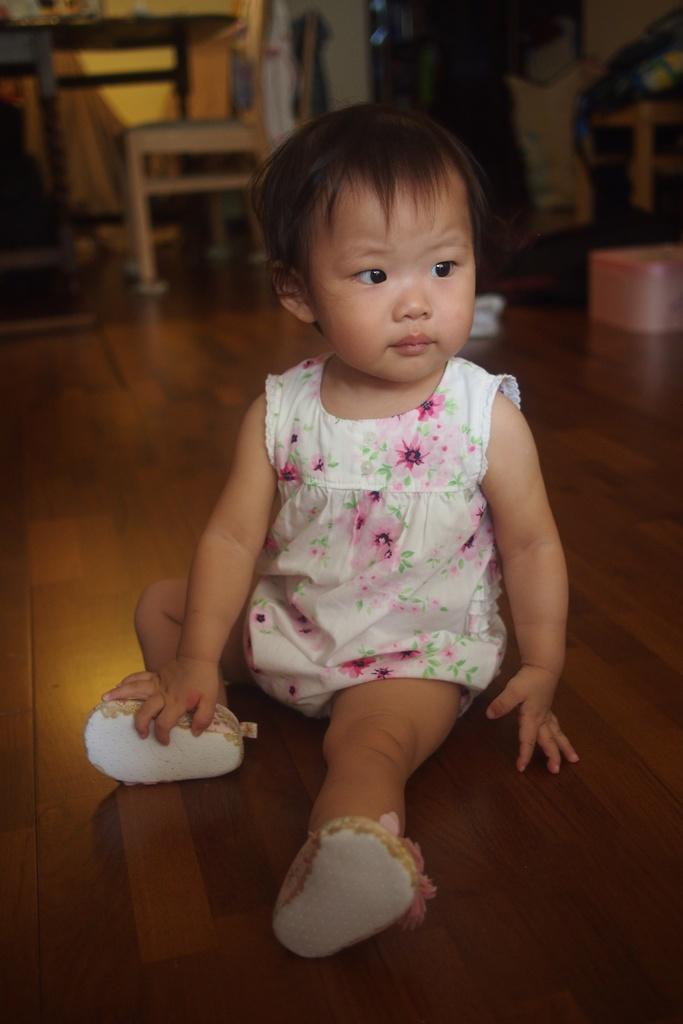What is the girl in the image doing? The girl is sitting on the floor in the image. What is the girl wearing? The girl is wearing a white frock and shoes. What can be seen in the background of the image? There is a chair and a table in the background. What objects are on the floor in the image? There appears to be a box and a cloth on the floor. How many cards is the girl holding in the image? There are no cards present in the image. What type of footwear is the girl wearing in the image? The girl is wearing shoes, but we cannot determine the specific type from the image. 